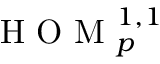Convert formula to latex. <formula><loc_0><loc_0><loc_500><loc_500>H O M _ { p } ^ { 1 , 1 }</formula> 